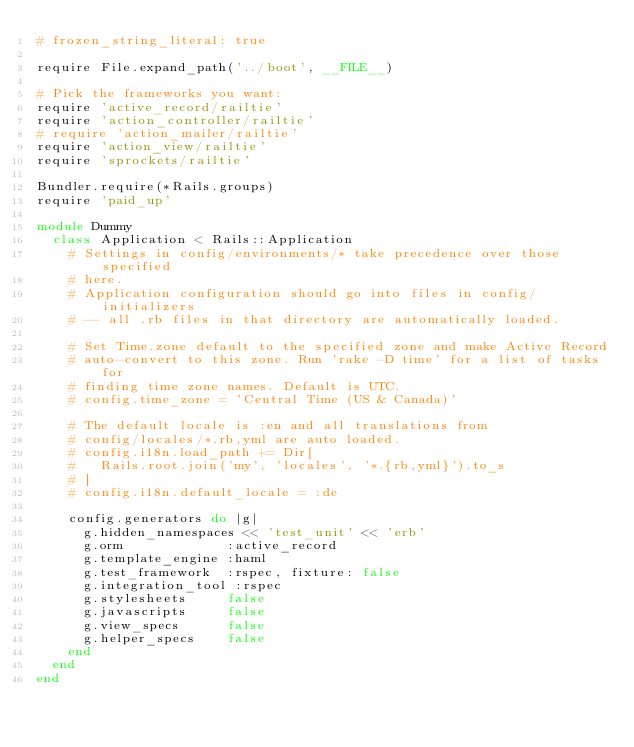Convert code to text. <code><loc_0><loc_0><loc_500><loc_500><_Ruby_># frozen_string_literal: true

require File.expand_path('../boot', __FILE__)

# Pick the frameworks you want:
require 'active_record/railtie'
require 'action_controller/railtie'
# require 'action_mailer/railtie'
require 'action_view/railtie'
require 'sprockets/railtie'

Bundler.require(*Rails.groups)
require 'paid_up'

module Dummy
  class Application < Rails::Application
    # Settings in config/environments/* take precedence over those specified
    # here.
    # Application configuration should go into files in config/initializers
    # -- all .rb files in that directory are automatically loaded.

    # Set Time.zone default to the specified zone and make Active Record
    # auto-convert to this zone. Run 'rake -D time' for a list of tasks for
    # finding time zone names. Default is UTC.
    # config.time_zone = 'Central Time (US & Canada)'

    # The default locale is :en and all translations from
    # config/locales/*.rb,yml are auto loaded.
    # config.i18n.load_path += Dir[
    #   Rails.root.join('my', 'locales', '*.{rb,yml}').to_s
    # ]
    # config.i18n.default_locale = :de

    config.generators do |g|
      g.hidden_namespaces << 'test_unit' << 'erb'
      g.orm             :active_record
      g.template_engine :haml
      g.test_framework  :rspec, fixture: false
      g.integration_tool :rspec
      g.stylesheets     false
      g.javascripts     false
      g.view_specs      false
      g.helper_specs    false
    end
  end
end</code> 